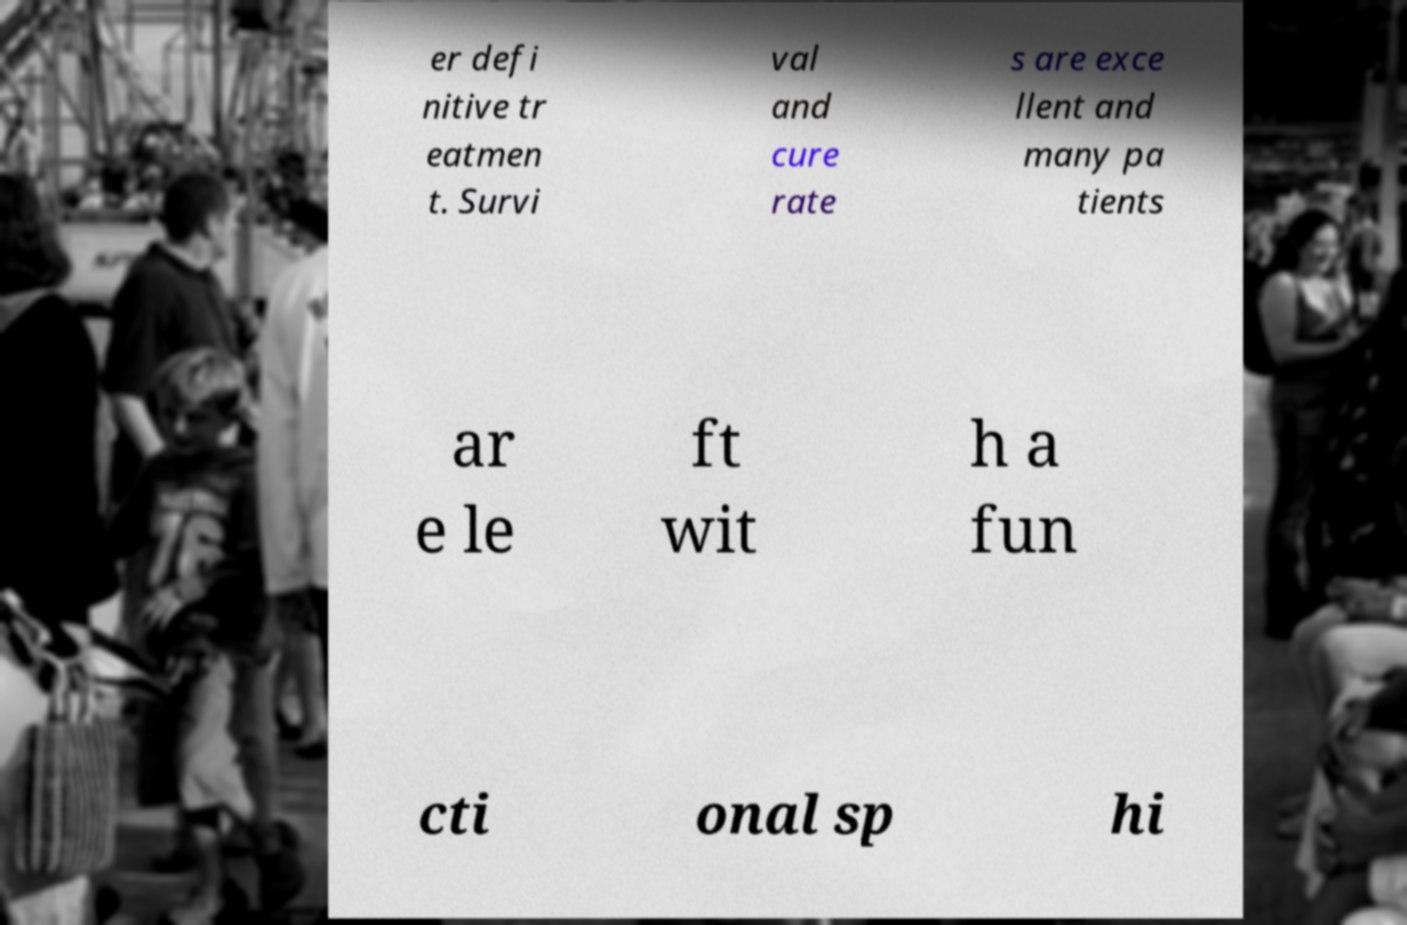For documentation purposes, I need the text within this image transcribed. Could you provide that? er defi nitive tr eatmen t. Survi val and cure rate s are exce llent and many pa tients ar e le ft wit h a fun cti onal sp hi 